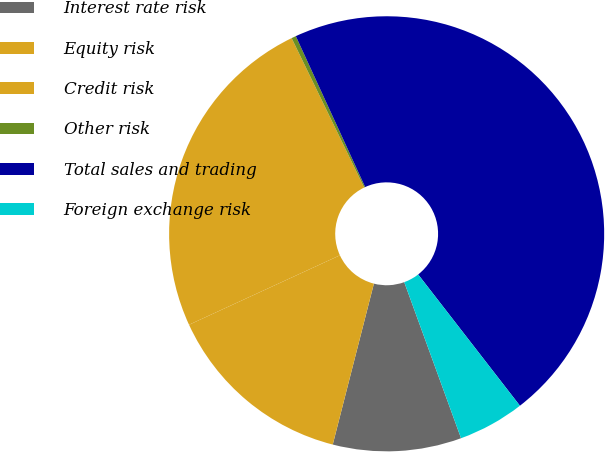Convert chart to OTSL. <chart><loc_0><loc_0><loc_500><loc_500><pie_chart><fcel>Interest rate risk<fcel>Equity risk<fcel>Credit risk<fcel>Other risk<fcel>Total sales and trading<fcel>Foreign exchange risk<nl><fcel>9.54%<fcel>14.15%<fcel>24.67%<fcel>0.34%<fcel>46.36%<fcel>4.94%<nl></chart> 